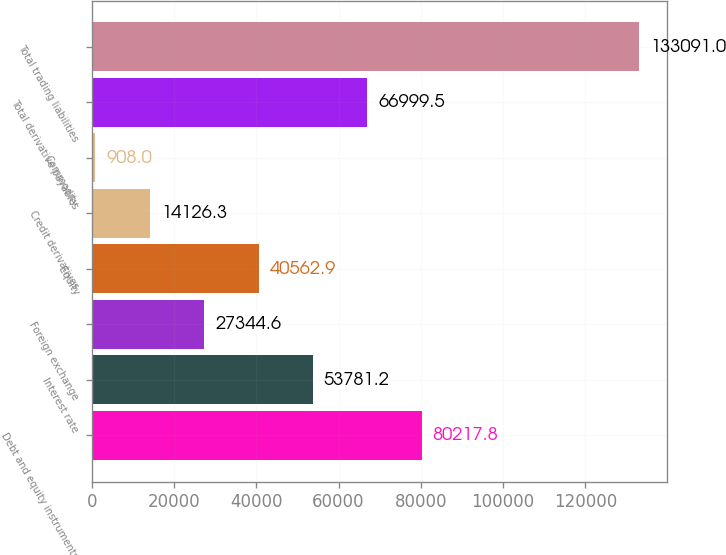Convert chart. <chart><loc_0><loc_0><loc_500><loc_500><bar_chart><fcel>Debt and equity instruments<fcel>Interest rate<fcel>Foreign exchange<fcel>Equity<fcel>Credit derivatives<fcel>Commodity<fcel>Total derivative payables<fcel>Total trading liabilities<nl><fcel>80217.8<fcel>53781.2<fcel>27344.6<fcel>40562.9<fcel>14126.3<fcel>908<fcel>66999.5<fcel>133091<nl></chart> 